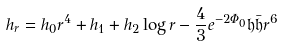Convert formula to latex. <formula><loc_0><loc_0><loc_500><loc_500>h _ { r } & = h _ { 0 } r ^ { 4 } + h _ { 1 } + h _ { 2 } \log r - \frac { 4 } { 3 } e ^ { - 2 \Phi _ { 0 } } \mathfrak { h } \bar { \mathfrak { h } } r ^ { 6 }</formula> 